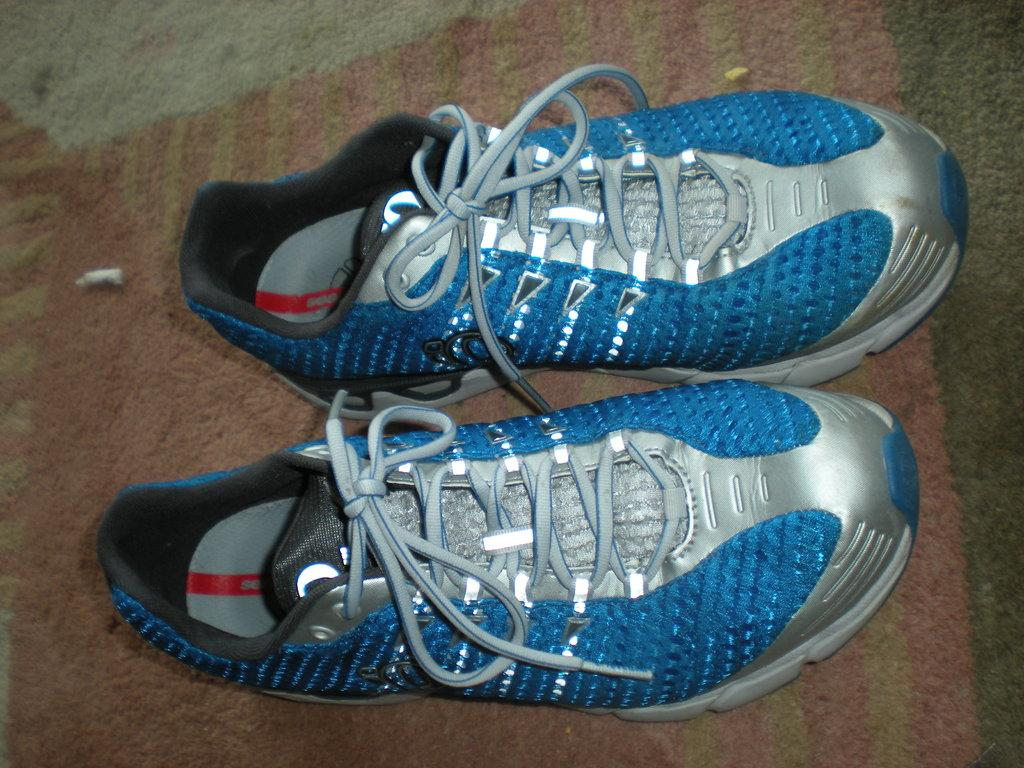What type of object is present in the image? There is a pair of shoes in the image. Can you describe the color of the shoes? The shoes are blue and silver in color. Where is the map located in the image? There is no map present in the image. What type of juice is being served in the image? There is no juice present in the image. 